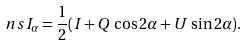<formula> <loc_0><loc_0><loc_500><loc_500>\ n s I _ { \alpha } = \frac { 1 } { 2 } ( I + Q \, \cos 2 \alpha + U \, \sin 2 \alpha ) .</formula> 